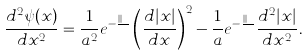Convert formula to latex. <formula><loc_0><loc_0><loc_500><loc_500>\frac { d ^ { 2 } \psi ( x ) } { d x ^ { 2 } } = \frac { 1 } { a ^ { 2 } } e ^ { - \frac { | x | } { a } } \left ( \frac { d | x | } { d x } \right ) ^ { 2 } - \frac { 1 } { a } e ^ { - \frac { | x | } { a } } \frac { d ^ { 2 } | x | } { d x ^ { 2 } } .</formula> 